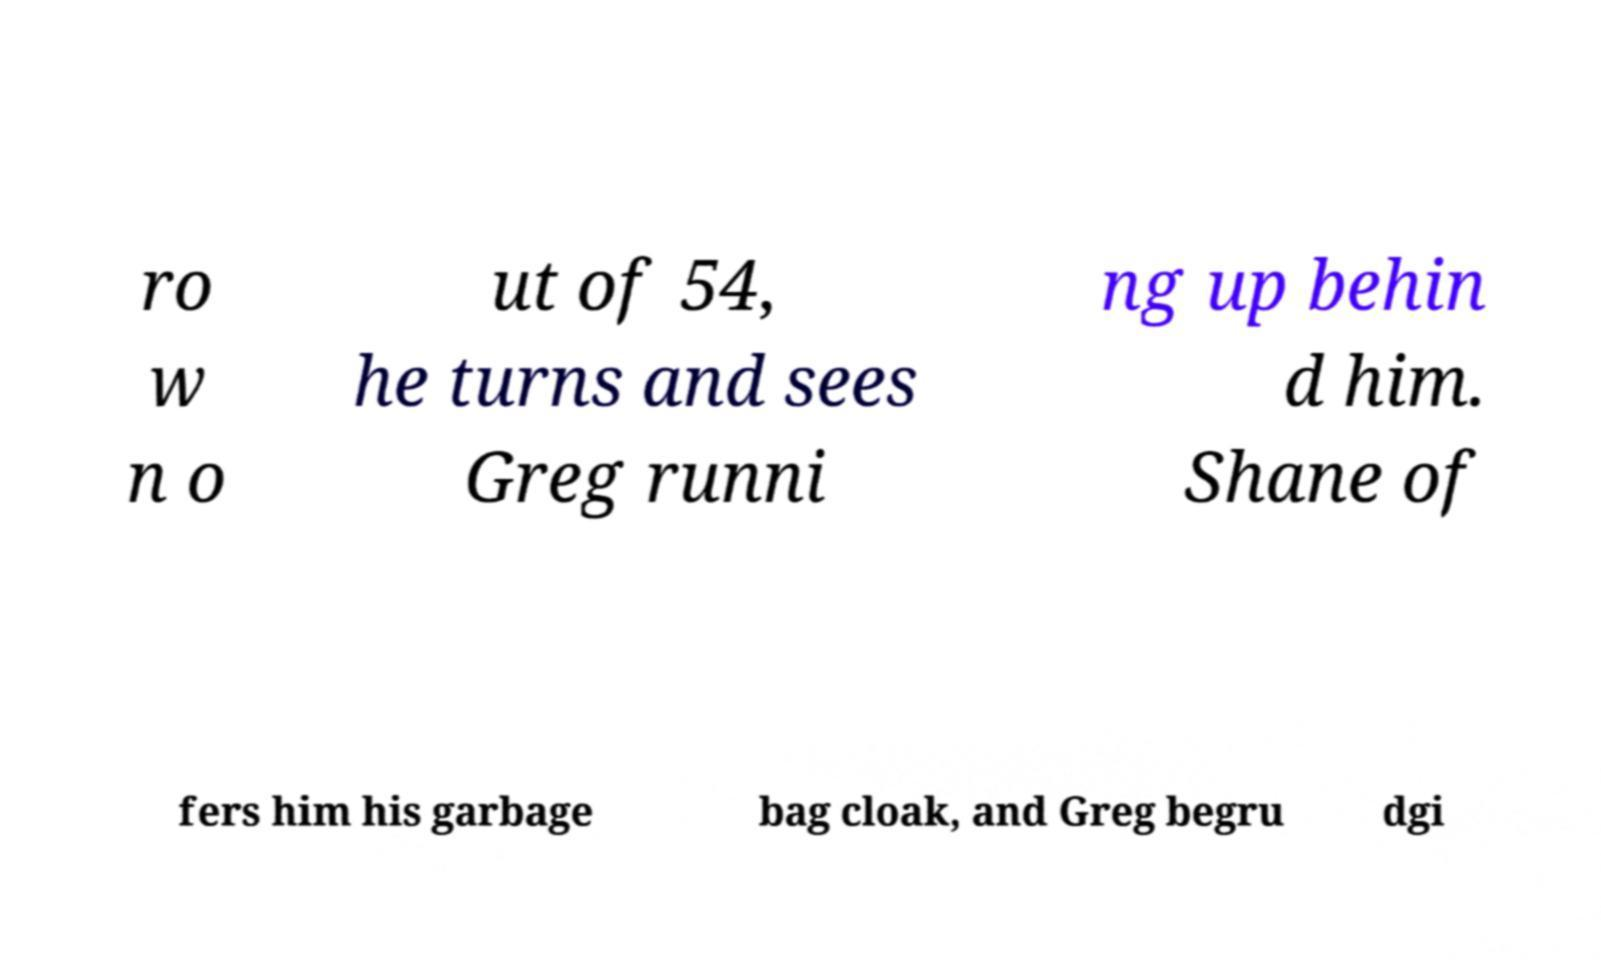Please read and relay the text visible in this image. What does it say? ro w n o ut of 54, he turns and sees Greg runni ng up behin d him. Shane of fers him his garbage bag cloak, and Greg begru dgi 